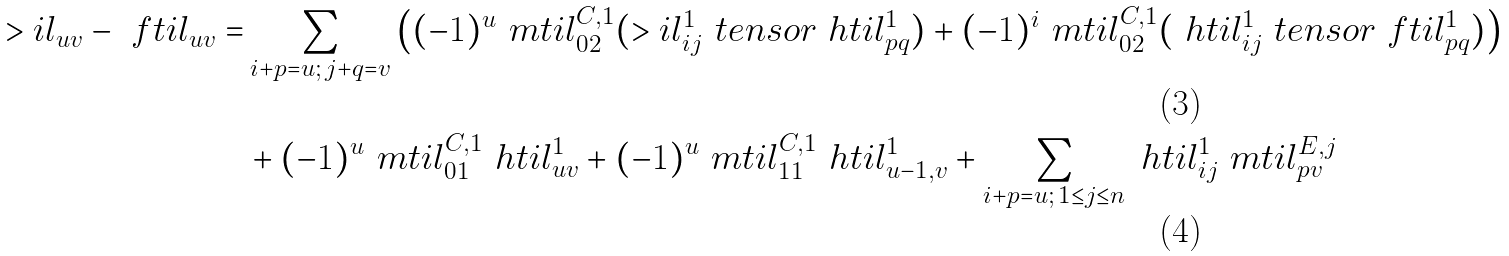<formula> <loc_0><loc_0><loc_500><loc_500>> i l _ { u v } - \ f t i l _ { u v } = & \sum _ { i + p = u ; \, j + q = v } \left ( ( - 1 ) ^ { u } \ m t i l _ { 0 2 } ^ { C , 1 } ( > i l _ { i j } ^ { 1 } \ t e n s o r \ h t i l ^ { 1 } _ { p q } ) + ( - 1 ) ^ { i } \ m t i l _ { 0 2 } ^ { C , 1 } ( \ h t i l ^ { 1 } _ { i j } \ t e n s o r \ f t i l _ { p q } ^ { 1 } ) \right ) \\ & + ( - 1 ) ^ { u } \ m t i l _ { 0 1 } ^ { C , 1 } \ h t i l ^ { 1 } _ { u v } + ( - 1 ) ^ { u } \ m t i l _ { 1 1 } ^ { C , 1 } \ h t i l ^ { 1 } _ { u - 1 , v } + \sum _ { i + p = u ; \, 1 \leq j \leq n } \ h t i l ^ { 1 } _ { i j } \ m t i l ^ { E , j } _ { p v }</formula> 